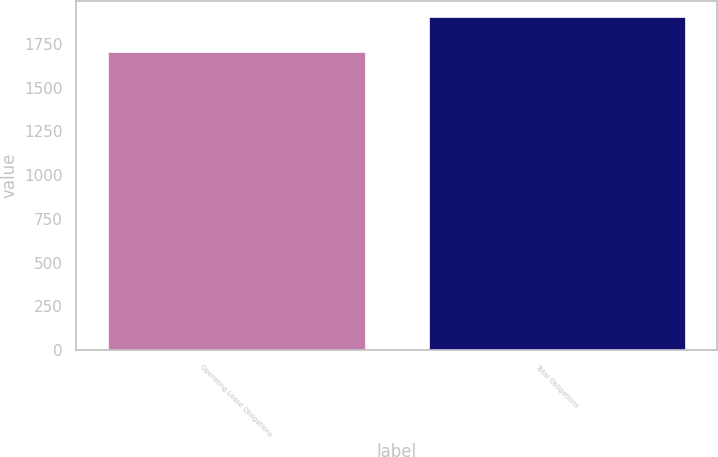Convert chart to OTSL. <chart><loc_0><loc_0><loc_500><loc_500><bar_chart><fcel>Operating Lease Obligations<fcel>Total Obligations<nl><fcel>1703<fcel>1903<nl></chart> 